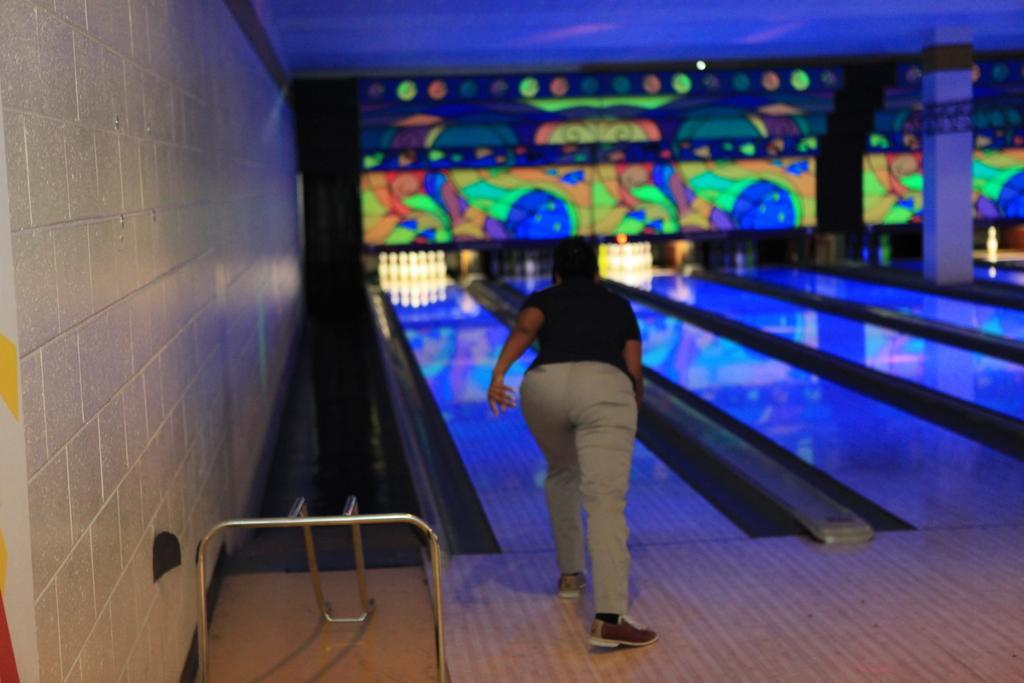Can you describe this image briefly? In this picture there is a person and we can see bowling game, wall, pillar, floor and rods. 